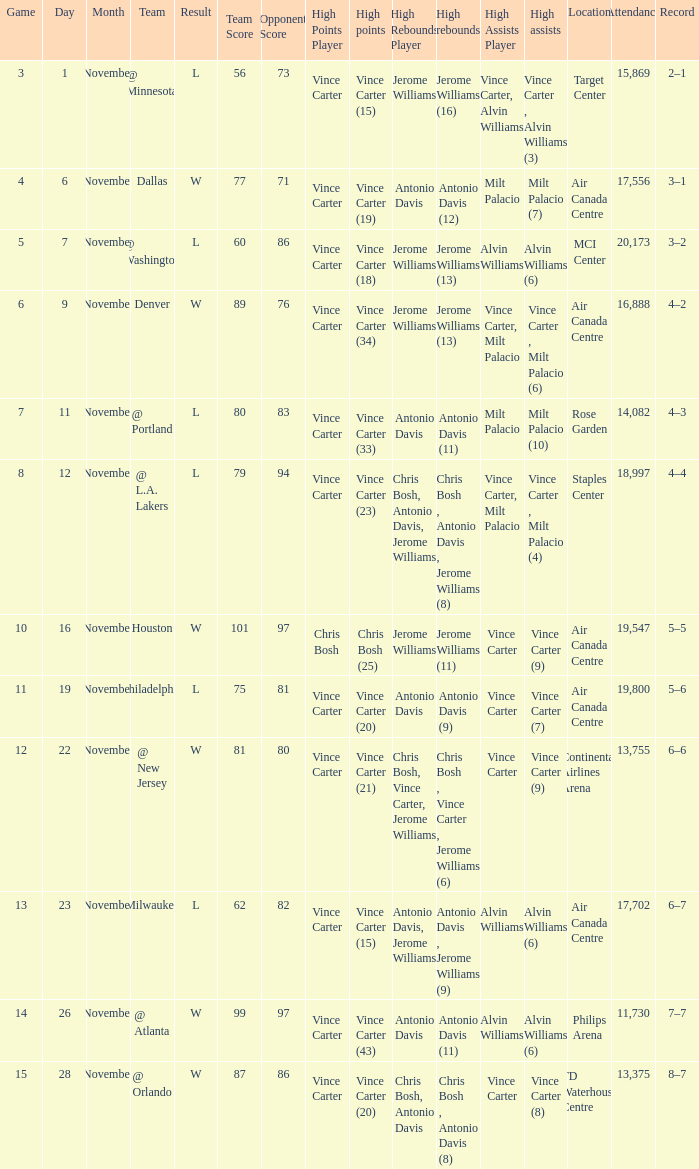On what date was the attendance at Continental Airlines Arena 13,755? November 22. 